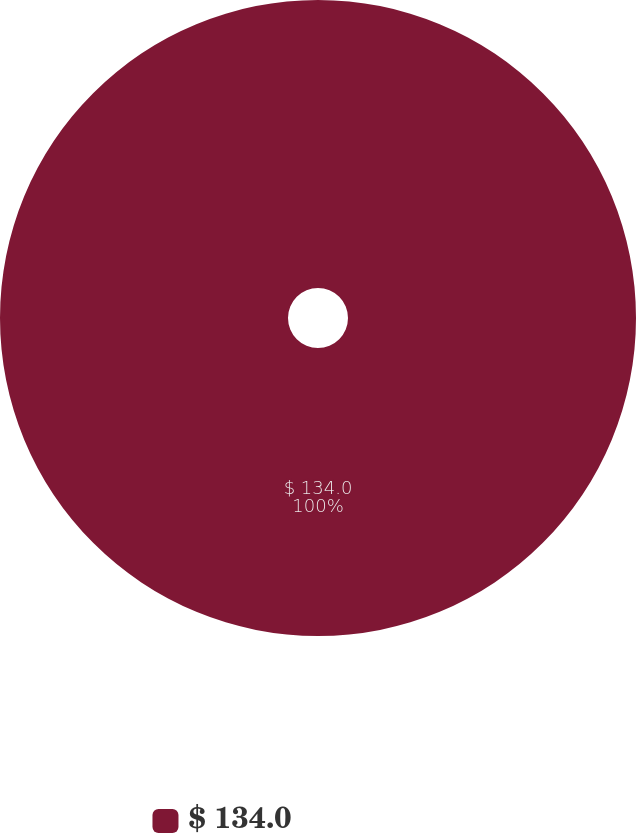Convert chart. <chart><loc_0><loc_0><loc_500><loc_500><pie_chart><fcel>$ 134.0<nl><fcel>100.0%<nl></chart> 